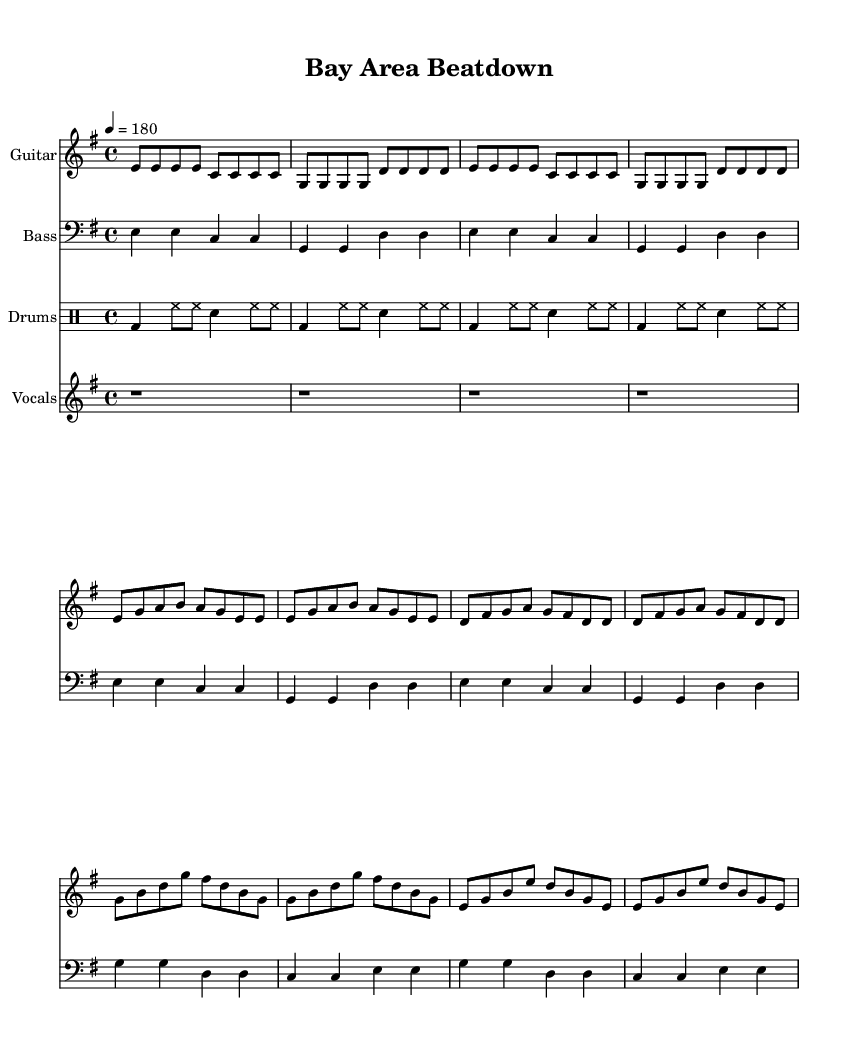What is the key signature of this music? The key signature is found at the beginning of the staff and indicates E minor, which has one sharp (F#).
Answer: E minor What is the time signature of this music? The time signature is located after the key signature and indicates it is in 4/4 time, which means there are four beats per measure.
Answer: 4/4 What is the tempo marking for this piece? The tempo marking is indicated by the notation "4 = 180", which means there are 180 beats per minute, giving it a fast-paced feel typical of punk music.
Answer: 180 How many bars are in the intro section? The intro consists of the first four measures of the sheet music; each measure is counted individually to determine the total number.
Answer: 4 What is the primary theme explored in the lyrics? The lyrics compare the success of LA sports teams to those of San Francisco, portraying LA as dominant and filled with pride, highlighting a rivalry through sports victories.
Answer: Rivalry What type of beat is used in the drum part? The drum part is specifically written in four-four time using a basic punk beat pattern, which is characterized by steady bass drum and snare hits along with persistent hi-hat rhythms.
Answer: Basic punk beat What is repeated multiple times in the chorus? The phrase "LA dominates, it's our destiny!" reflects a sense of victory and pride for Los Angeles, repeated to emphasize the theme of the song.
Answer: “LA dominates” 